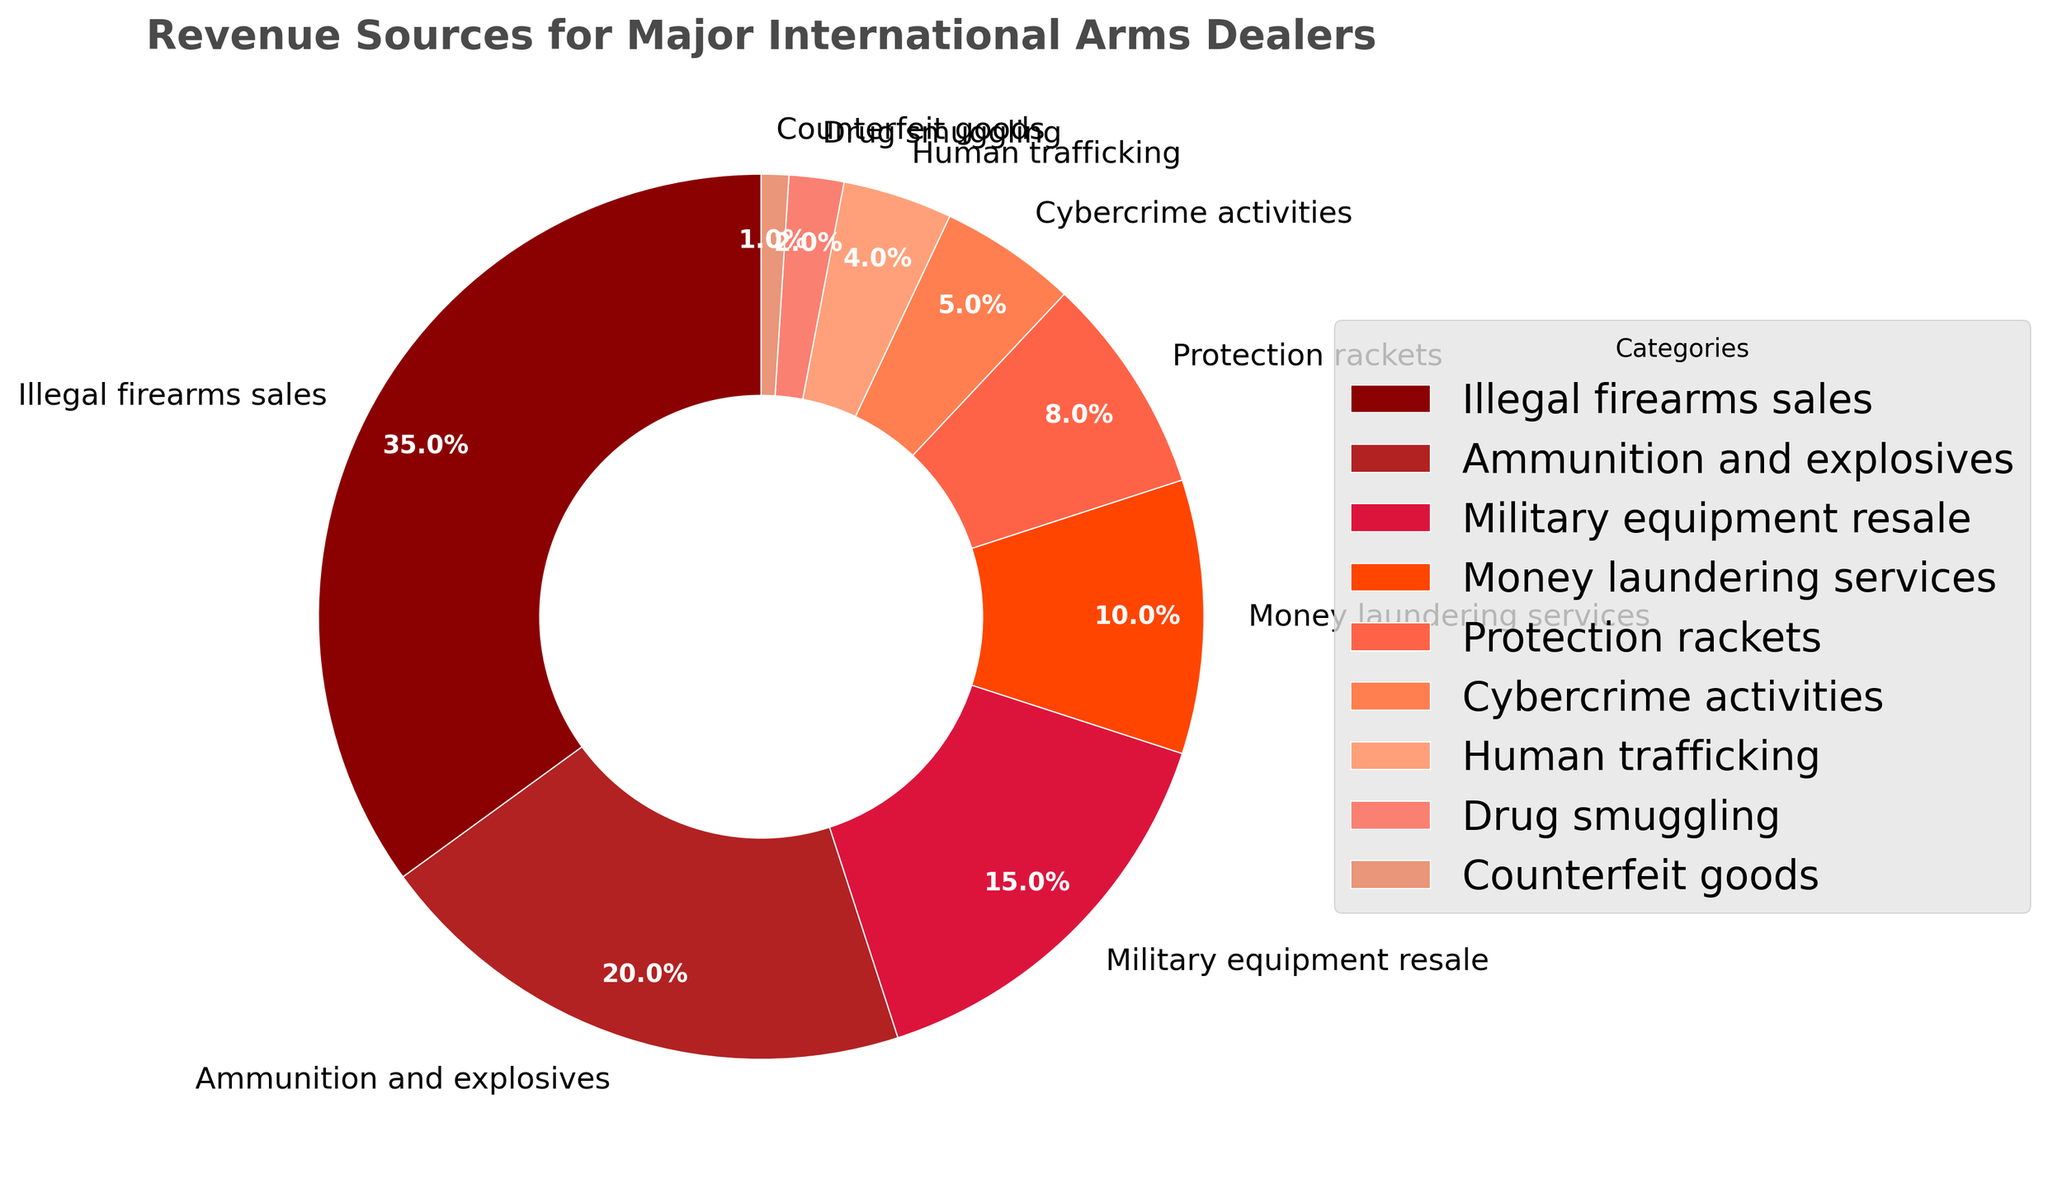What's the title of the pie chart? The title of a chart is usually positioned at the top and is intended to give a clear summary of the chart's content. In this case, the title reads "Revenue Sources for Major International Arms Dealers," indicating the subject of the percentage breakdown.
Answer: Revenue Sources for Major International Arms Dealers Which revenue source contributes the most to the total revenue? The pie chart visually represents revenue sources with various sized segments. The largest segment indicates the highest revenue. Here, "Illegal firearms sales" takes up the largest portion of the pie chart.
Answer: Illegal firearms sales How much combined percentage do "Military equipment resale" and "Human trafficking" contribute? To find the combined percentage, add the percentages of the individual categories. For "Military equipment resale" (15%) and "Human trafficking" (4%), you get 15% + 4% = 19%.
Answer: 19% What is the smallest revenue source, and what percent does it contribute? The smallest segment in the pie chart represents the least significant revenue source. Here, "Counterfeit goods" is the smallest, contributing 1%.
Answer: Counterfeit goods, 1% Compare the percentage contributions of "Money laundering services" and "Protection rackets." Which one contributes a higher percentage? By comparing the segments, "Money laundering services" contribute 10%, while "Protection rackets" contribute 8%. Thus, "Money laundering services" have a higher percentage.
Answer: Money laundering services What is the sum of the percentages for "Cybercrime activities," "Human trafficking," and "Drug smuggling"? To find this, you add the percentages of these categories. For "Cybercrime activities" (5%), "Human trafficking" (4%), and "Drug smuggling" (2%), the sum is 5% + 4% + 2% = 11%.
Answer: 11% Which revenue source is just above "Ammunition and explosives" in the percentage contribution? The chart arranges segments by size. "Ammunition and explosives" contribute 20%, and the next largest segment is "Illegal firearms sales" at 35%.
Answer: Illegal firearms sales 